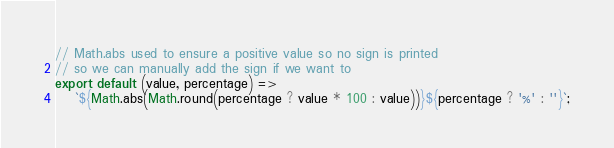<code> <loc_0><loc_0><loc_500><loc_500><_JavaScript_>// Math.abs used to ensure a positive value so no sign is printed
// so we can manually add the sign if we want to
export default (value, percentage) =>
	`${Math.abs(Math.round(percentage ? value * 100 : value))}${percentage ? '%' : ''}`;
</code> 